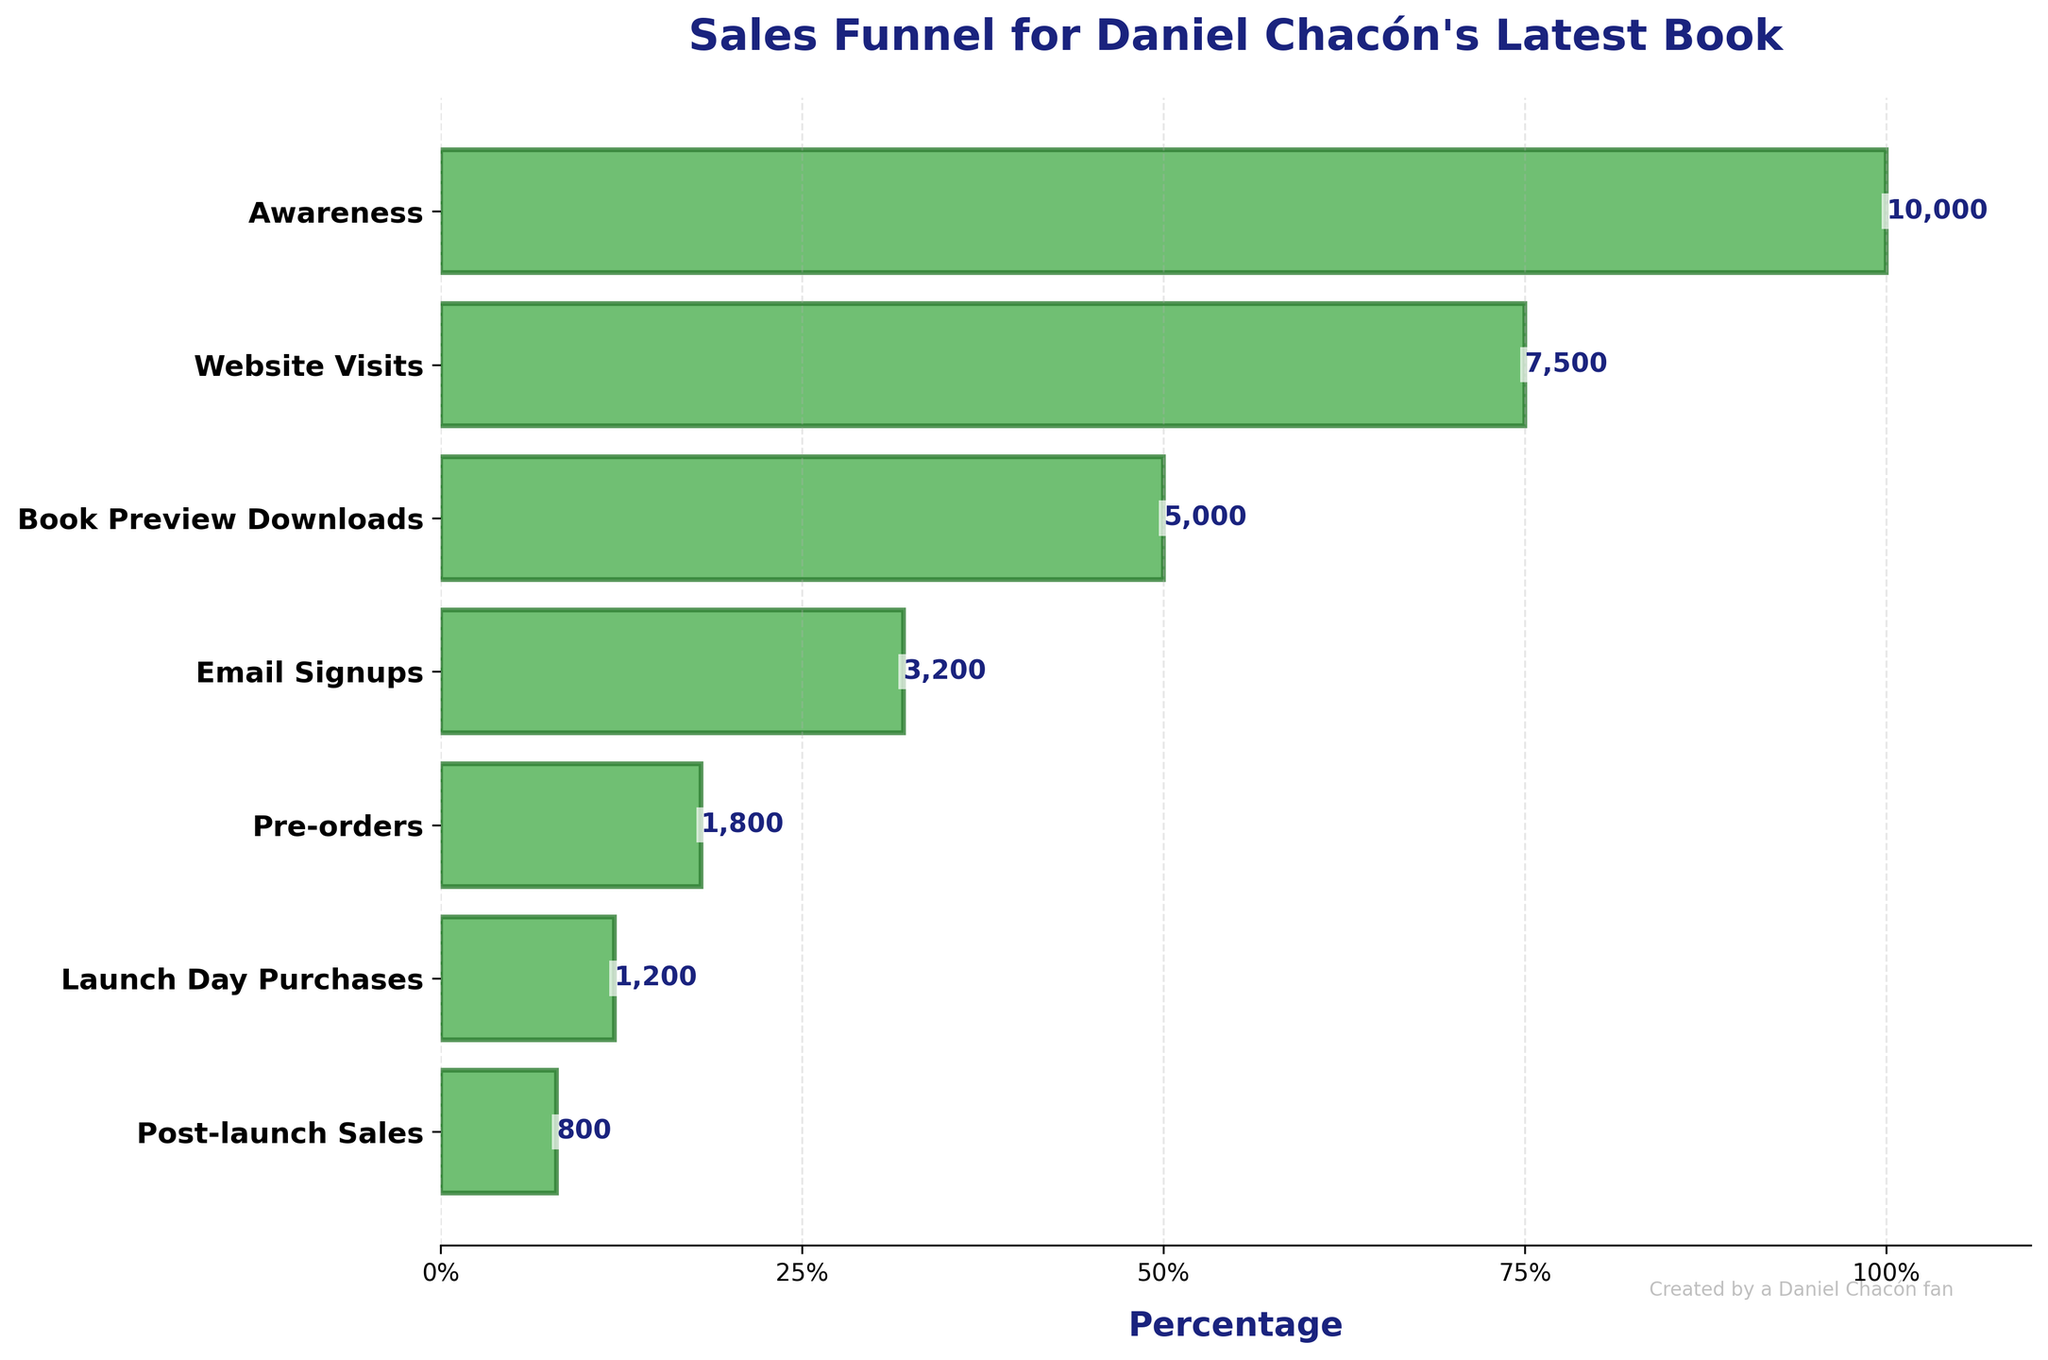What's the title of the chart? The title of the chart is written at the top and describes the overall content of the chart. It reads "Sales Funnel for Daniel Chacón's Latest Book".
Answer: Sales Funnel for Daniel Chacón's Latest Book How many stages are depicted in the funnel? By counting the number of horizontal bars in the funnel chart, we can determine there are seven stages depicted.
Answer: 7 Which stage has the highest count? The stage with the longest bar and the value closest to 1 on the x-axis represents the highest count, which is the "Awareness" stage.
Answer: Awareness Which stage has the lowest count? The stage with the shortest bar and the value closest to 0 on the x-axis represents the lowest count, which is the "Post-launch Sales" stage.
Answer: Post-launch Sales How many counts are there at the "Book Preview Downloads" stage? By reading the label text near the bar corresponding to the "Book Preview Downloads" stage, it shows 5,000 counts at this stage.
Answer: 5000 What is the difference in count between "Pre-orders" and "Launch Day Purchases" stages? The "Pre-orders" stage has 1,800 and the "Launch Day Purchases" stage has 1,200. The difference is 1,800 - 1,200 = 600.
Answer: 600 Which stage follows "Email Signups" in the sales funnel? The next lower horizontal bar after "Email Signups" is "Pre-orders", according to the inverted y-axis labels.
Answer: Pre-orders How many stages have a count of more than 5000? By examining the horizontal bars, "Awareness", "Website Visits", and "Book Preview Downloads" stages have counts more than 5,000. There are 3 such stages.
Answer: 3 What's the percentage decrease from "Awareness" to "Website Visits"? The count decreases from 10,000 ("Awareness") to 7,500 ("Website Visits"). The percentage decrease can be calculated as ((10,000 - 7,500) / 10,000) * 100 = 25%.
Answer: 25% What’s the combined count for "Launch Day Purchases" and "Post-launch Sales"? Adding the counts of "Launch Day Purchases" (1,200) and "Post-launch Sales" (800) gives 1,200 + 800 = 2,000.
Answer: 2000 